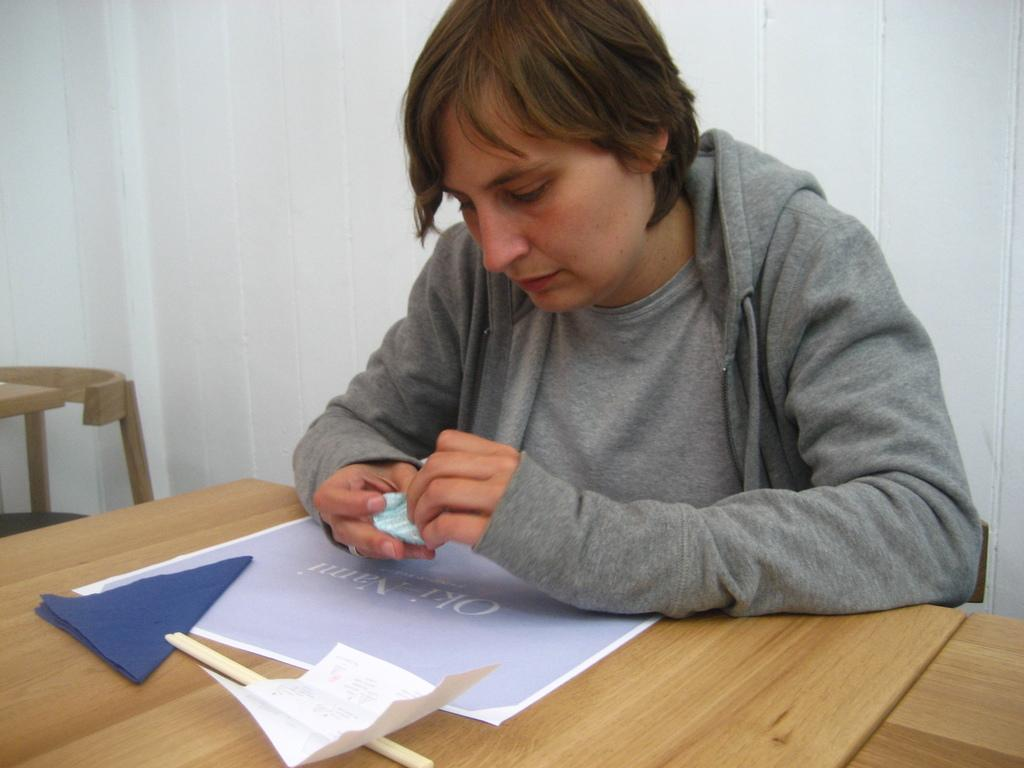What is the person holding in the image? There is a person holding an object in the image. What type of furniture can be seen in the image? There are tables and a chair in the image. What is hanging on the wall in the background of the image? There is a poster in the image. What type of writing material is present in the image? There are papers in the image. What utensil is visible in the image? There are chopsticks in the image. What type of background can be seen in the image? There is a wall in the background of the image. What type of question is being asked in the image? There is no question being asked in the image; it only shows a person holding an object, tables, a chair, a poster, papers, chopsticks, and a wall. 